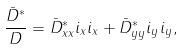Convert formula to latex. <formula><loc_0><loc_0><loc_500><loc_500>\frac { \bar { D } ^ { \ast } } { D } = \bar { D } ^ { \ast } _ { x x } i _ { x } i _ { x } + \bar { D } ^ { \ast } _ { y y } i _ { y } i _ { y } ,</formula> 